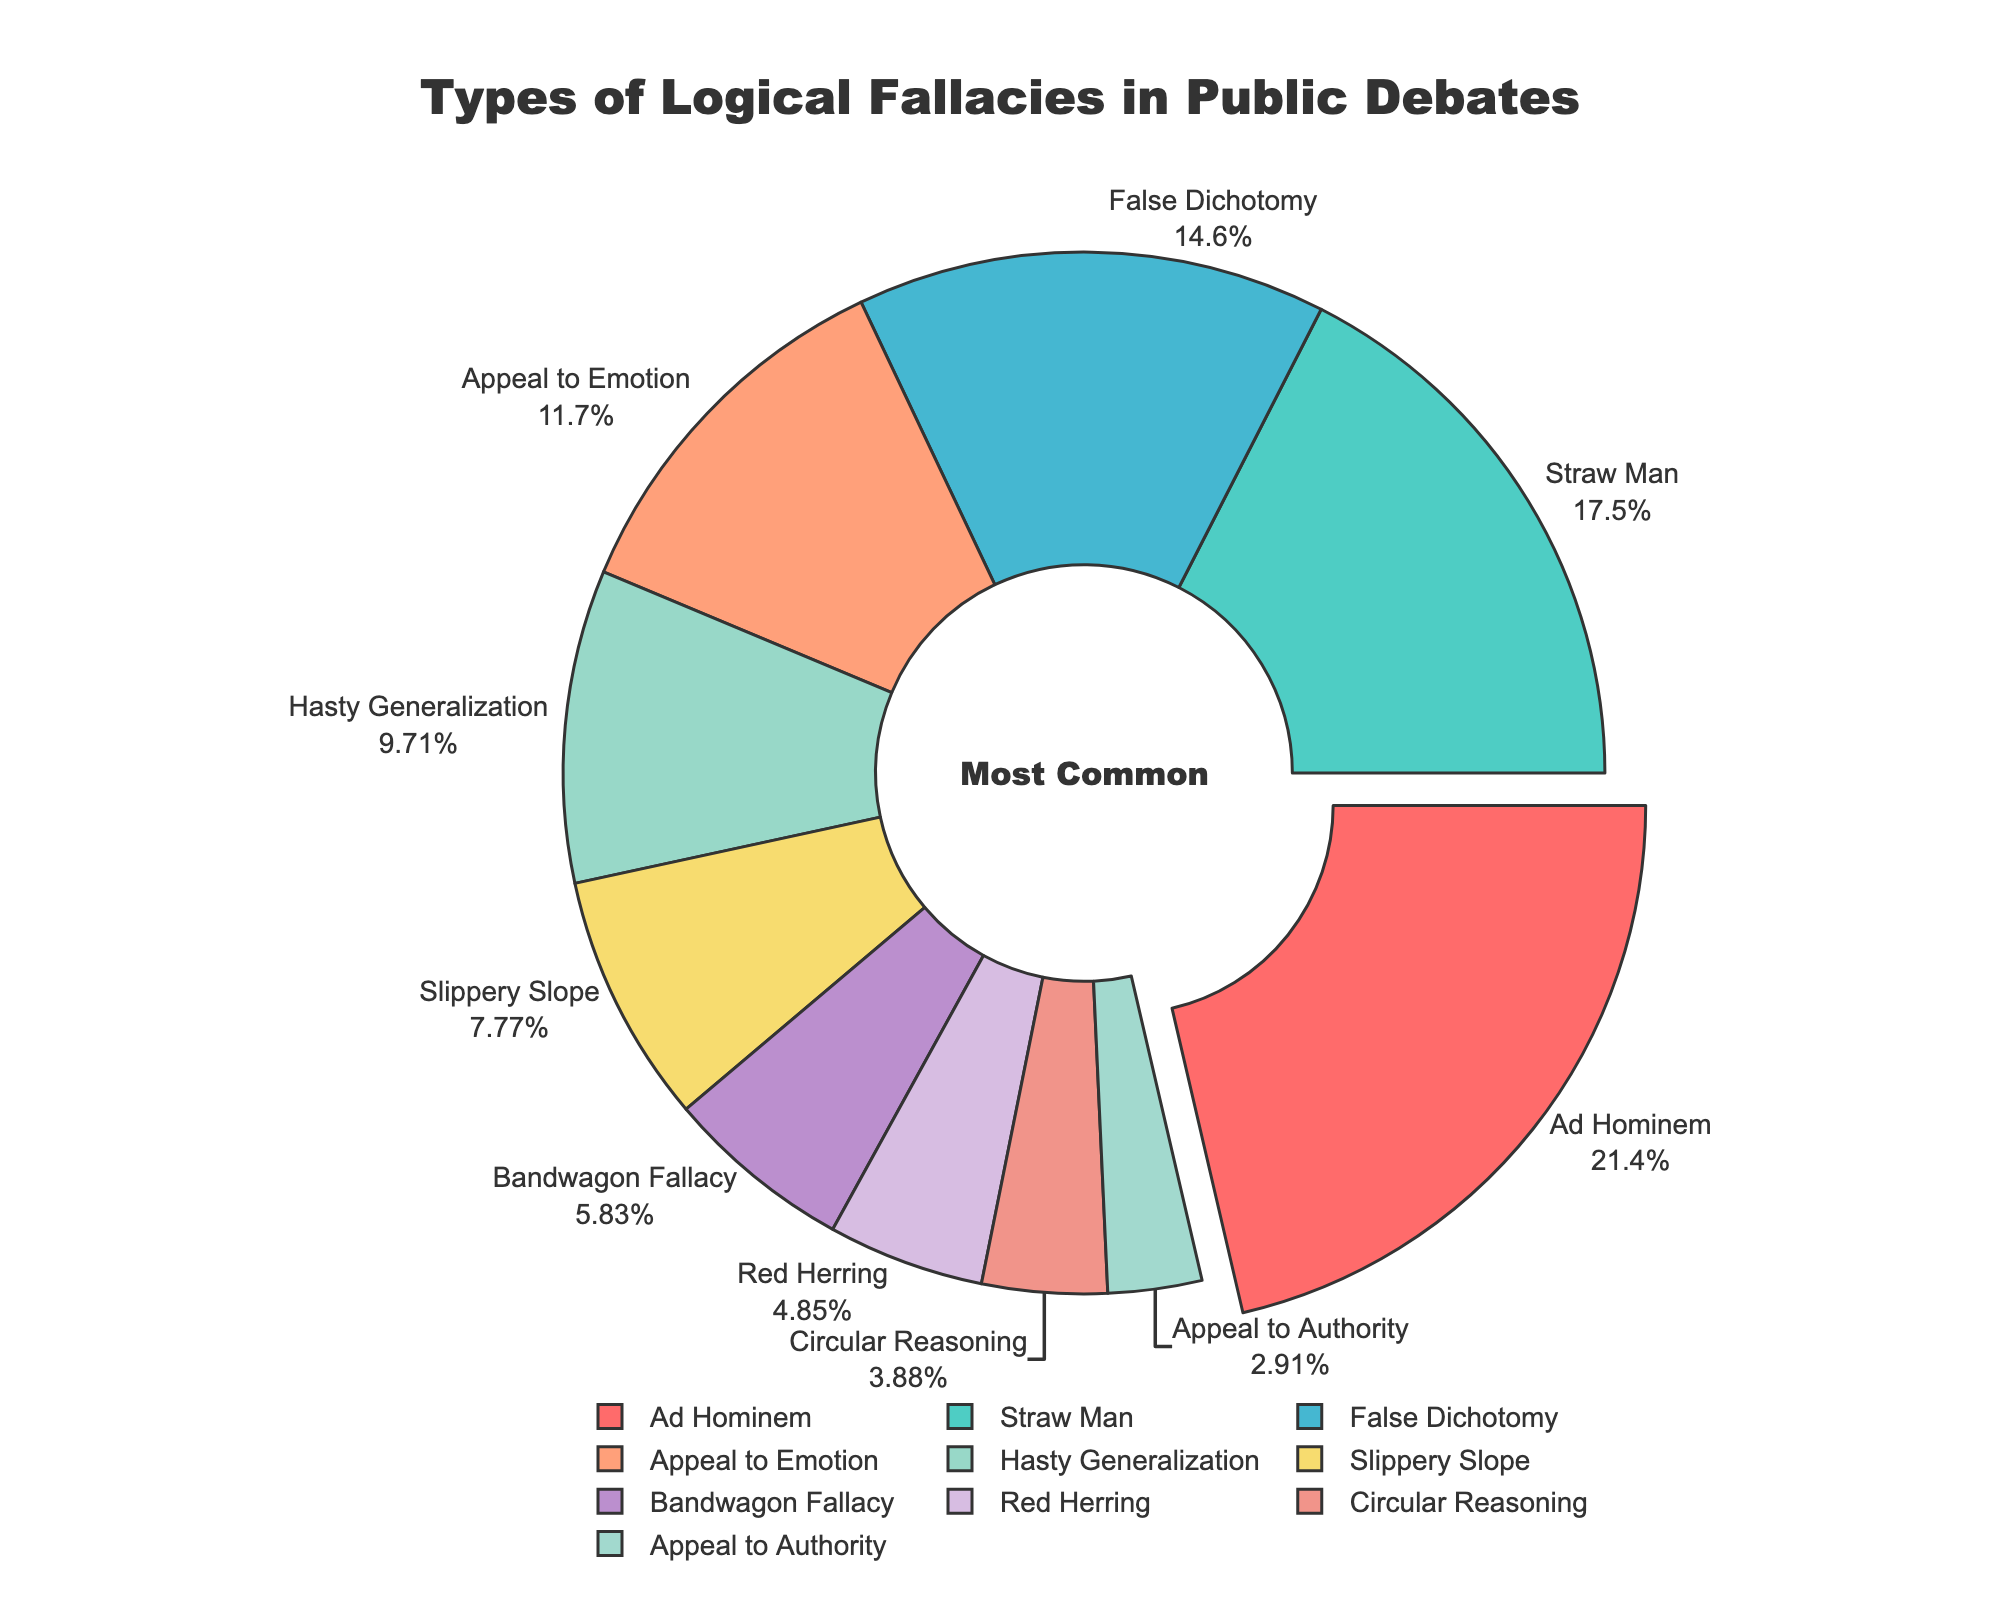Ad Hominem is highlighted more prominently. What percentage does it constitute? The Ad Hominem section is visually accented by being slightly pulled out. According to the pie chart, it constitutes 22% of the data.
Answer: 22% Which logical fallacy has the smallest percentage in the chart? The pie chart indicates that the Appeal to Authority section is the smallest, as it is visually represented by the smallest slice. This fallacy accounts for 3% of the data.
Answer: Appeal to Authority Compare the frequencies of the Ad Hominem and Straw Man fallacies. Which is more common, and by how much? According to the chart, Ad Hominem is more common (22%) compared to Straw Man (18%). The difference is calculated as 22% - 18% = 4%.
Answer: Ad Hominem by 4% Are the combined percentages of Hasty Generalization and Slippery Slope higher than that of Ad Hominem? Hasty Generalization accounts for 10% and Slippery Slope for 8%. Combined, they add up to 10% + 8% = 18%, which is less than Ad Hominem's 22%.
Answer: No Which fallacy represents 10% of the dataset? By inspecting the pie chart, the slice labeled Hasty Generalization represents 10% of the data.
Answer: Hasty Generalization Considering the percentages, what is the second most common fallacy? The chart shows that Ad Hominem is the most common at 22%. The next largest slice, at 18%, represents Straw Man, making it the second most common fallacy.
Answer: Straw Man If you sum the percentages of Straw Man and False Dichotomy, what is the result? Straw Man accounts for 18% and False Dichotomy for 15%. Adding these together, we get 18% + 15% = 33%.
Answer: 33% How many fallacies are represented by a slice with a percentage of 5% or less? The chart indicates only the Red Herring (5%), Circular Reasoning (4%), and Appeal to Authority (3%). That’s three fallacies with 5% or less.
Answer: 3 Compare the total percentage of Bandwagon Fallacy and Red Herring against False Dichotomy. Which total is larger and by how much? Bandwagon Fallacy has 6% and Red Herring has 5%, summing to 6% + 5% = 11%. False Dichotomy alone is 15%. Thus, False Dichotomy is larger by 15% - 11% = 4%.
Answer: False Dichotomy by 4% What is the cumulative percentage of the least common four fallacies? The least common four fallacies are Appeal to Authority (3%), Circular Reasoning (4%), Red Herring (5%), and Bandwagon Fallacy (6%). Adding these together, we get 3% + 4% + 5% + 6% = 18%.
Answer: 18% 